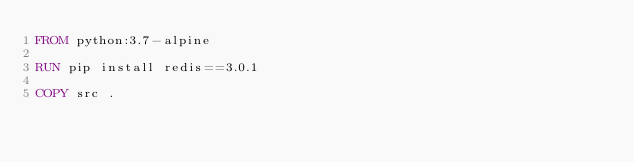Convert code to text. <code><loc_0><loc_0><loc_500><loc_500><_Dockerfile_>FROM python:3.7-alpine

RUN pip install redis==3.0.1

COPY src .</code> 